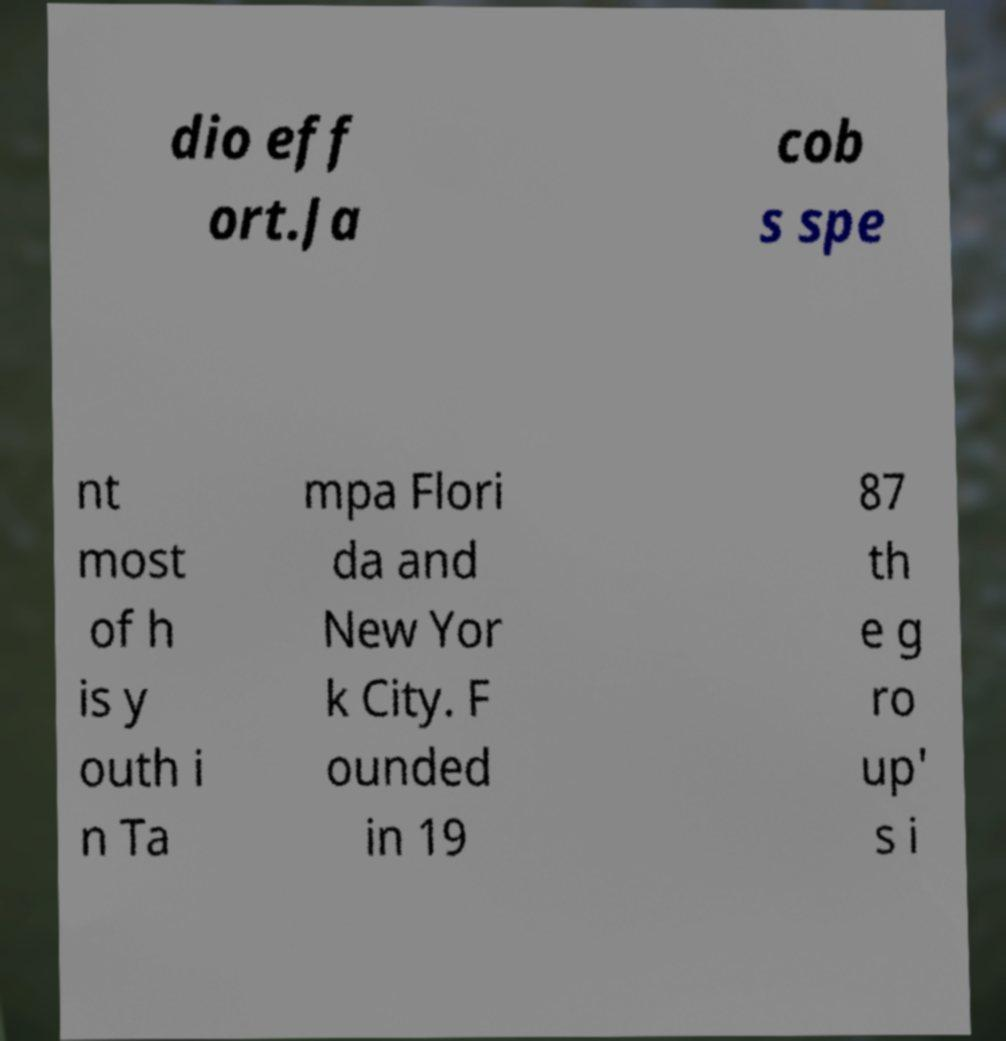Could you extract and type out the text from this image? dio eff ort.Ja cob s spe nt most of h is y outh i n Ta mpa Flori da and New Yor k City. F ounded in 19 87 th e g ro up' s i 